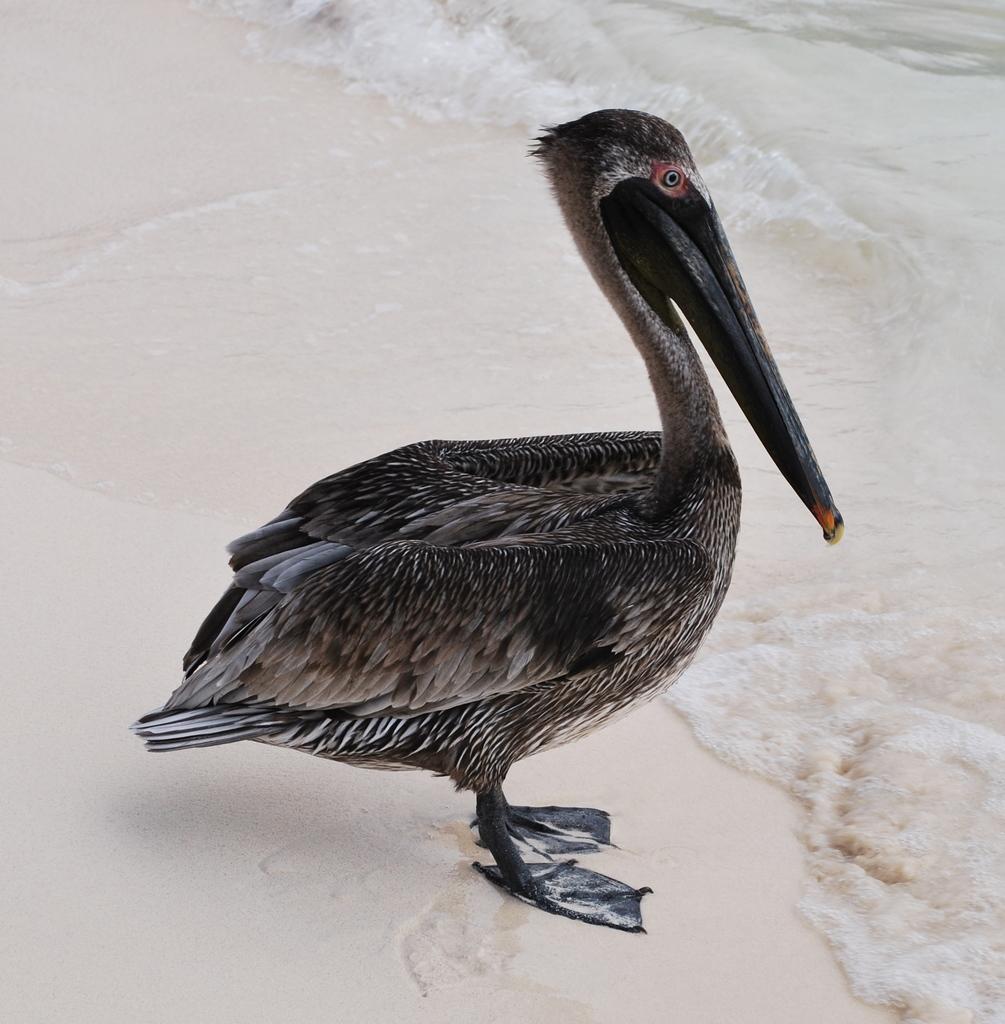Can you describe this image briefly? In this picture, it seems like a duck in the foreground on the sand and water in the background. 